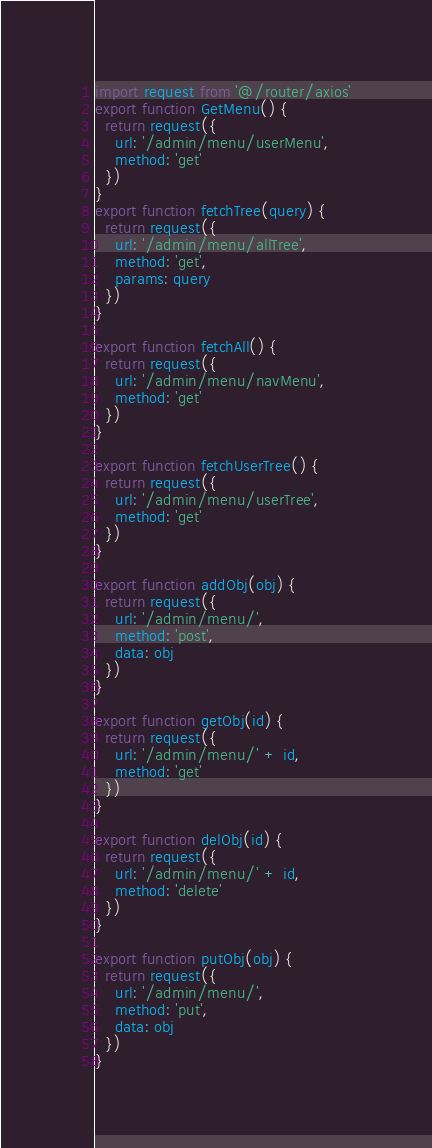<code> <loc_0><loc_0><loc_500><loc_500><_JavaScript_>import request from '@/router/axios'
export function GetMenu() {
  return request({
    url: '/admin/menu/userMenu',
    method: 'get'
  })
}
export function fetchTree(query) {
  return request({
    url: '/admin/menu/allTree',
    method: 'get',
    params: query
  })
}

export function fetchAll() {
  return request({
    url: '/admin/menu/navMenu',
    method: 'get'
  })
}

export function fetchUserTree() {
  return request({
    url: '/admin/menu/userTree',
    method: 'get'
  })
}

export function addObj(obj) {
  return request({
    url: '/admin/menu/',
    method: 'post',
    data: obj
  })
}

export function getObj(id) {
  return request({
    url: '/admin/menu/' + id,
    method: 'get'
  })
}

export function delObj(id) {
  return request({
    url: '/admin/menu/' + id,
    method: 'delete'
  })
}

export function putObj(obj) {
  return request({
    url: '/admin/menu/',
    method: 'put',
    data: obj
  })
}
</code> 